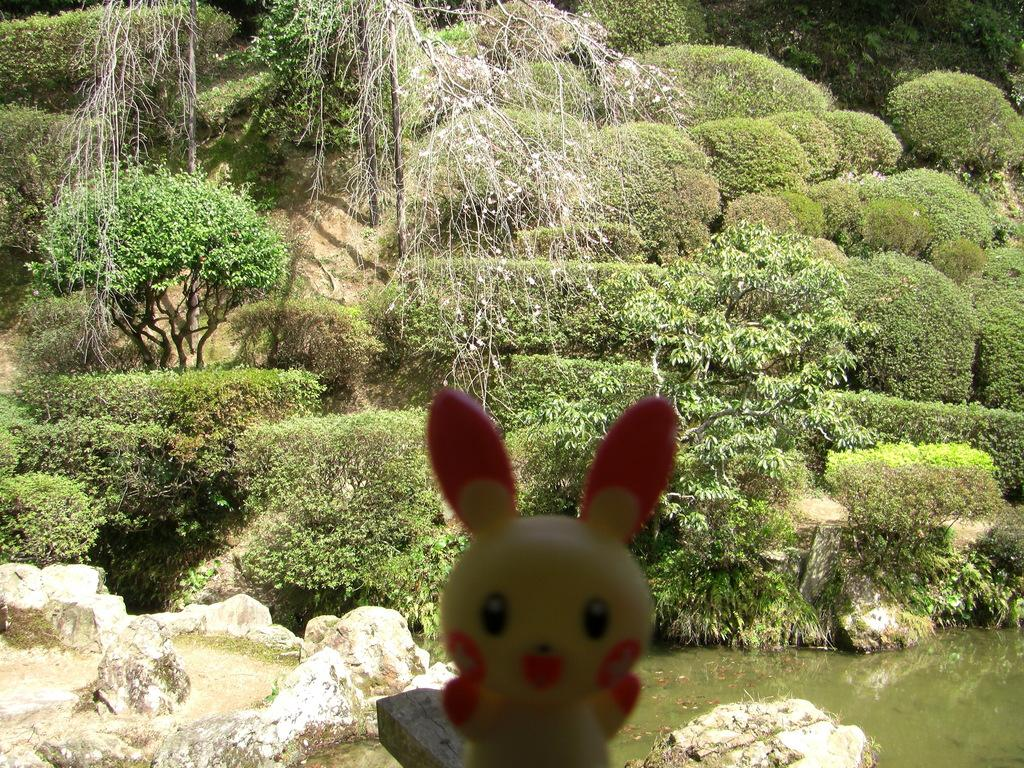What is located in the foreground of the image? There is a toy in the foreground of the image. What can be seen in the background of the image? There are trees visible in the background of the image. What type of terrain is present at the bottom of the image? There are stones at the bottom of the image. What natural element is visible in the image? There is water visible in the image. What type of flesh can be seen on the toy in the image? There is no flesh visible on the toy in the image, as it is likely an inanimate object. 